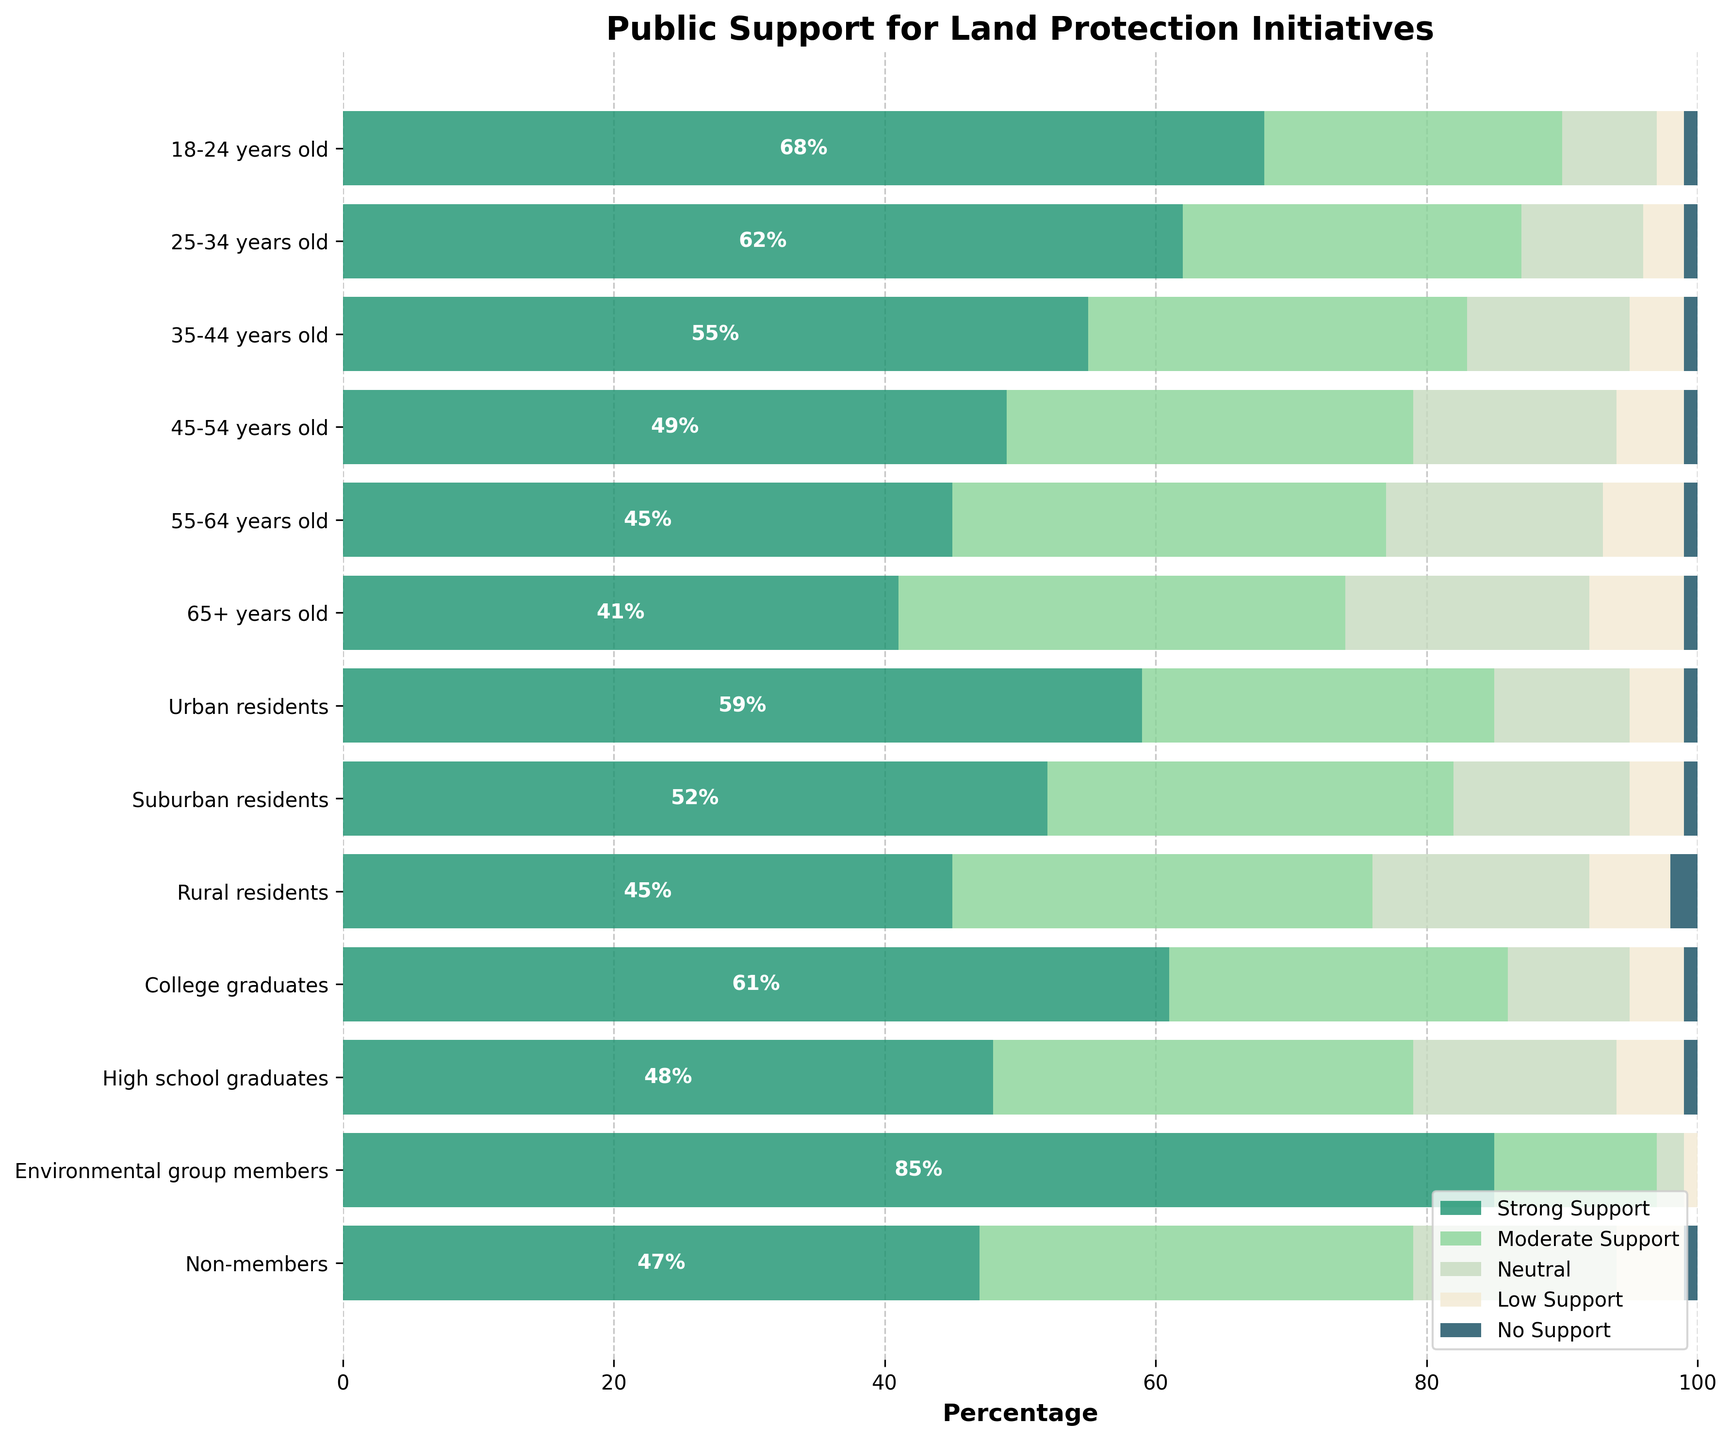What's the title of the figure? The title is usually at the top of the figure. It provides a summary of what the figure is about. Refer to the decorated text at the top.
Answer: Public Support for Land Protection Initiatives Which demographic group shows the highest percentage of strong support for land protection initiatives? Look for the longest green bar corresponding to the "Strong Support" category in the horizontal bars.
Answer: Environmental group members What is the combined percentage of strong and moderate support among 18-24 year olds? Find the strong and moderate support percentages for 18-24 years old and add them together: 68% strong + 22% moderate = 90%.
Answer: 90% How does the level of low support among rural residents compare to urban residents? Check the length of the yellow bars for low support among rural and urban residents. Rural has 6%, and Urban has 4%.
Answer: Rural residents have higher low support (6% vs. 4%) Which demographic group shows the least neutral stance on land protection initiatives? Look for the shortest light yellow bar corresponding to the "Neutral" category in the horizontal bars.
Answer: Environmental group members What percentage of no support is seen among the groups? How do they compare? Find the lengths of the dark blue bars for the "No Support" category across all groups. They range from 0% to 2%.
Answer: All groups have similar low levels, mostly at 1%, except Environmental group members at 0% Which age group has the highest moderate support for land protection initiatives? Look for the longest greenish-blue bar corresponding to the "Moderate Support" category within the age groups.
Answer: 65+ years old What is the total percentage of neutral and low support among high school graduates? Add the percentages of neutral and low support for high school graduates: 15% neutral + 5% low = 20%.
Answer: 20% How does the strong support among suburban residents compare to urban residents? Compare the lengths of the green bars for "Strong Support" between suburban and urban residents. Urban: 59%, Suburban: 52%.
Answer: Suburban residents have lower strong support (52% vs. 59%) What is the overall pattern you see in the relationship between age and strong support for land protection initiatives? Look at the trend in the lengths of the green bars for "Strong Support" as age increases. The bars get shorter, suggesting a decrease in strong support with increasing age.
Answer: Strong support decreases with age 